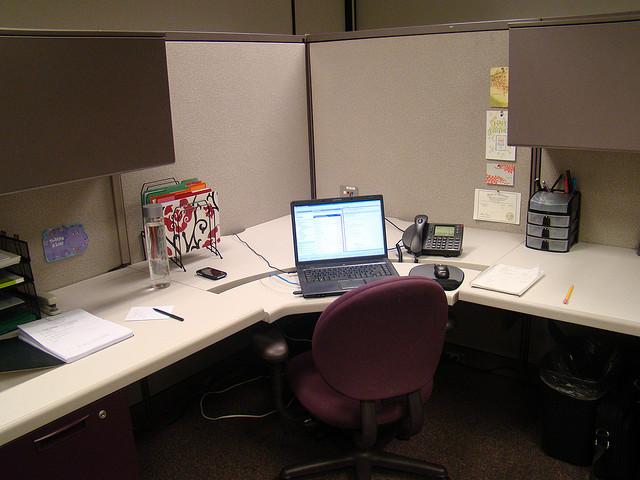Whose office is this?
Write a very short answer. Worker. Is this a home office?
Concise answer only. No. Is this a professional office?
Be succinct. Yes. Is the laptop open?
Answer briefly. Yes. What type of computer is this?
Short answer required. Laptop. 